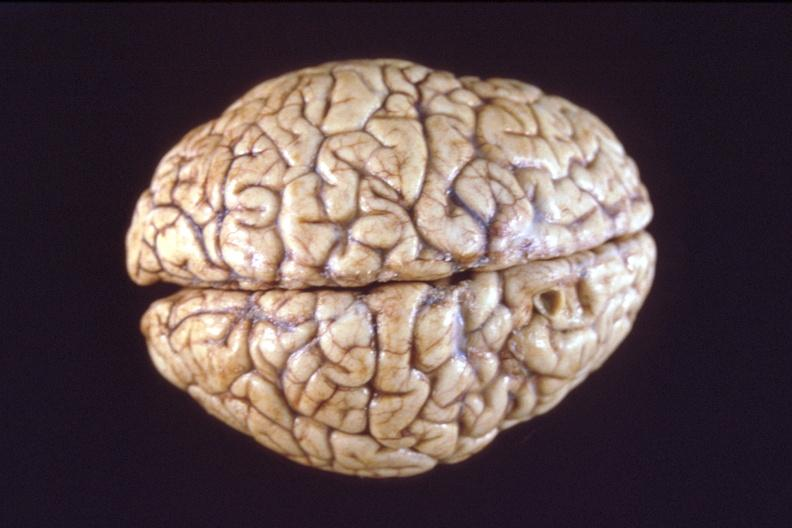s thecoma present?
Answer the question using a single word or phrase. No 